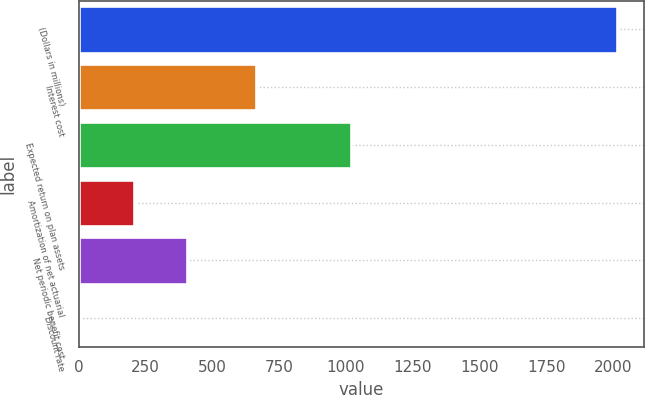Convert chart to OTSL. <chart><loc_0><loc_0><loc_500><loc_500><bar_chart><fcel>(Dollars in millions)<fcel>Interest cost<fcel>Expected return on plan assets<fcel>Amortization of net actuarial<fcel>Net periodic benefit cost<fcel>Discount rate<nl><fcel>2014<fcel>665<fcel>1018<fcel>205.77<fcel>406.69<fcel>4.85<nl></chart> 